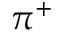Convert formula to latex. <formula><loc_0><loc_0><loc_500><loc_500>\pi ^ { + }</formula> 